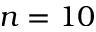Convert formula to latex. <formula><loc_0><loc_0><loc_500><loc_500>n = 1 0</formula> 